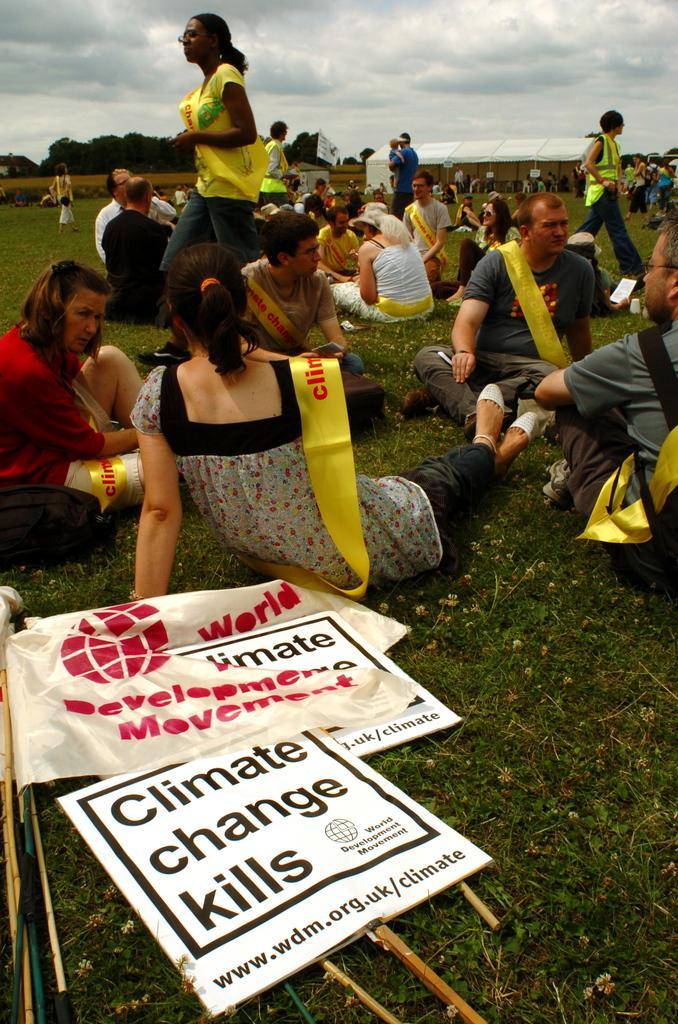In one or two sentences, can you explain what this image depicts? In this image, we can see people and are wearing sashes. In the background, there are trees and there are boards and flags. At the top, there are clouds in the sky. 